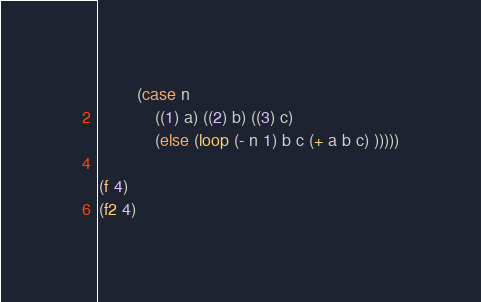<code> <loc_0><loc_0><loc_500><loc_500><_Scheme_>        (case n
            ((1) a) ((2) b) ((3) c) 
            (else (loop (- n 1) b c (+ a b c) )))))

(f 4)
(f2 4)</code> 